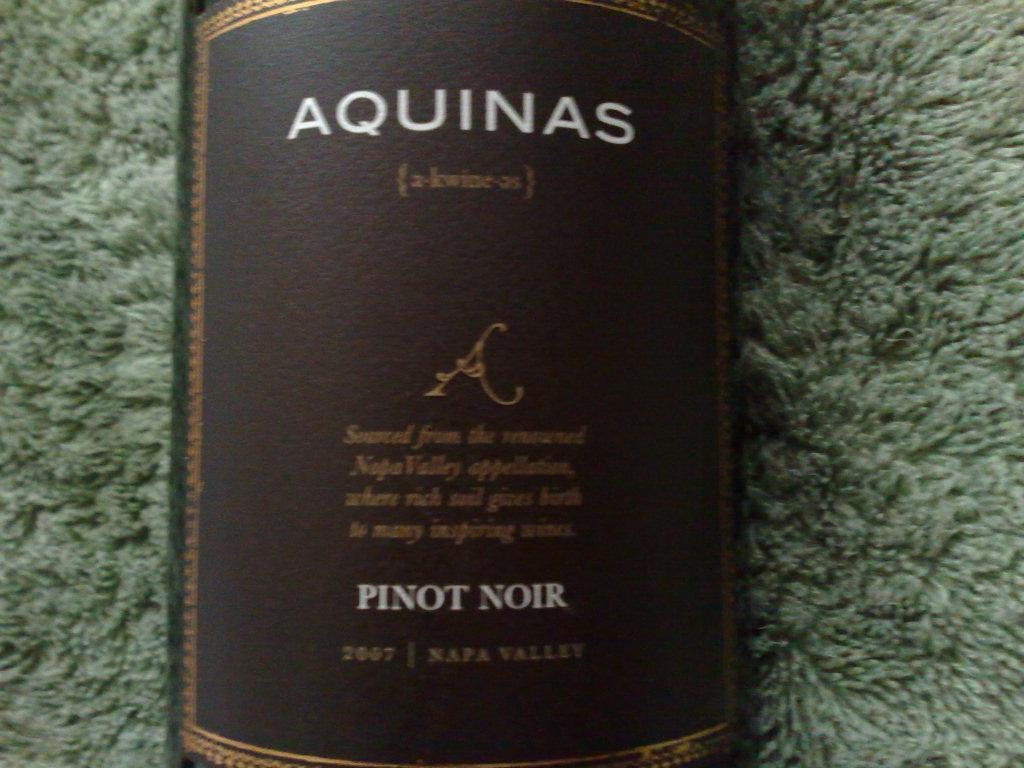<image>
Give a short and clear explanation of the subsequent image. An old brown Aquinas bottle of Pinot Noir 